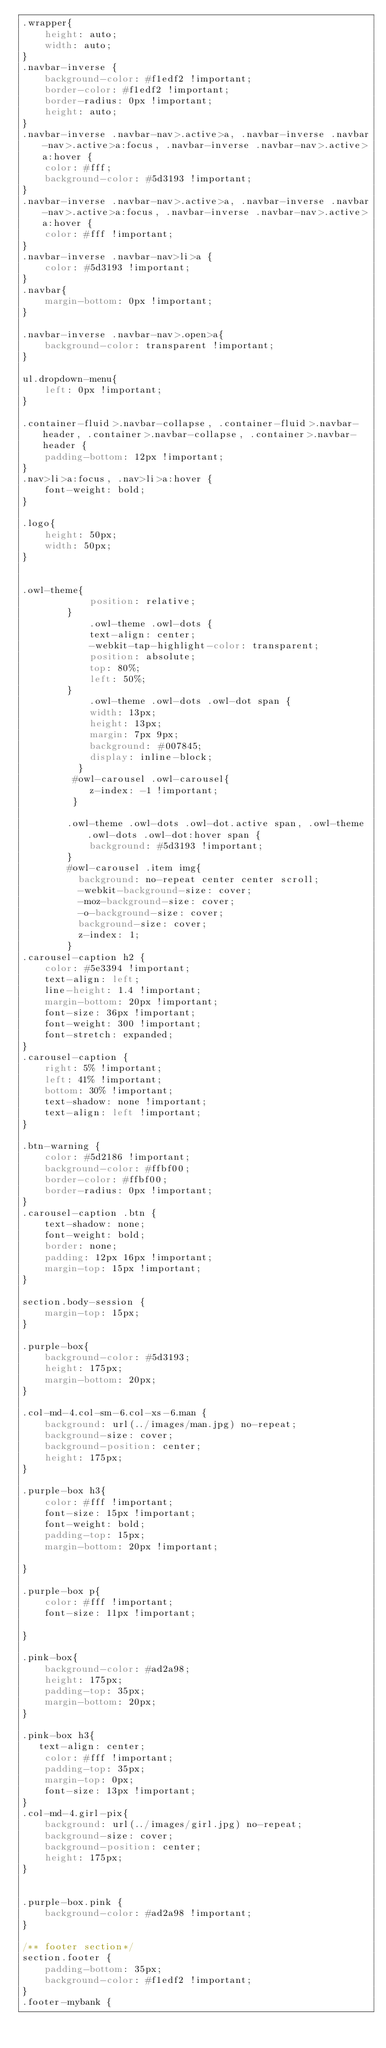Convert code to text. <code><loc_0><loc_0><loc_500><loc_500><_CSS_>.wrapper{
	height: auto;
	width: auto;
}
.navbar-inverse {
    background-color: #f1edf2 !important;
    border-color: #f1edf2 !important;
    border-radius: 0px !important;
    height: auto;
}
.navbar-inverse .navbar-nav>.active>a, .navbar-inverse .navbar-nav>.active>a:focus, .navbar-inverse .navbar-nav>.active>a:hover {
    color: #fff;
    background-color: #5d3193 !important;
}
.navbar-inverse .navbar-nav>.active>a, .navbar-inverse .navbar-nav>.active>a:focus, .navbar-inverse .navbar-nav>.active>a:hover {
    color: #fff !important;
}
.navbar-inverse .navbar-nav>li>a {
    color: #5d3193 !important;
}
.navbar{
    margin-bottom: 0px !important;
}

.navbar-inverse .navbar-nav>.open>a{
    background-color: transparent !important;
}

ul.dropdown-menu{
    left: 0px !important;
}

.container-fluid>.navbar-collapse, .container-fluid>.navbar-header, .container>.navbar-collapse, .container>.navbar-header {
    padding-bottom: 12px !important;
}
.nav>li>a:focus, .nav>li>a:hover {
    font-weight: bold;
}

.logo{
    height: 50px;
    width: 50px;
}


.owl-theme{
            position: relative;
        }
            .owl-theme .owl-dots {
            text-align: center;
            -webkit-tap-highlight-color: transparent;
            position: absolute;
            top: 80%;
            left: 50%;
        }
            .owl-theme .owl-dots .owl-dot span {
            width: 13px;
            height: 13px;
            margin: 7px 9px;
            background: #007845;
            display: inline-block;
          }
         #owl-carousel .owl-carousel{
            z-index: -1 !important;
         }

        .owl-theme .owl-dots .owl-dot.active span, .owl-theme .owl-dots .owl-dot:hover span {
            background: #5d3193 !important;
        }
        #owl-carousel .item img{
          background: no-repeat center center scroll;
          -webkit-background-size: cover;
          -moz-background-size: cover;
          -o-background-size: cover;
          background-size: cover;  
          z-index: 1;
        }
.carousel-caption h2 {
    color: #5e3394 !important;
    text-align: left;
    line-height: 1.4 !important;
    margin-bottom: 20px !important;
    font-size: 36px !important;
    font-weight: 300 !important;
    font-stretch: expanded;
}
.carousel-caption {
    right: 5% !important;
    left: 41% !important;
    bottom: 30% !important;
    text-shadow: none !important;
    text-align: left !important;
}

.btn-warning {
    color: #5d2186 !important;
    background-color: #ffbf00;
    border-color: #ffbf00;
    border-radius: 0px !important;
}
.carousel-caption .btn {
    text-shadow: none;
    font-weight: bold;
    border: none;
    padding: 12px 16px !important;
    margin-top: 15px !important;
}

section.body-session {
    margin-top: 15px;
}

.purple-box{
    background-color: #5d3193;
    height: 175px;
    margin-bottom: 20px;
}

.col-md-4.col-sm-6.col-xs-6.man {
    background: url(../images/man.jpg) no-repeat;
    background-size: cover;
    background-position: center;
    height: 175px;
}

.purple-box h3{
    color: #fff !important;
    font-size: 15px !important;
    font-weight: bold;
    padding-top: 15px;
    margin-bottom: 20px !important;

}

.purple-box p{
    color: #fff !important;
    font-size: 11px !important;
    
}

.pink-box{
    background-color: #ad2a98;
    height: 175px;
    padding-top: 35px;
    margin-bottom: 20px;
}

.pink-box h3{
   text-align: center;
    color: #fff !important;
    padding-top: 35px;
    margin-top: 0px;
    font-size: 13px !important;
}
.col-md-4.girl-pix{
    background: url(../images/girl.jpg) no-repeat;
    background-size: cover;
    background-position: center;
    height: 175px;
}


.purple-box.pink {
    background-color: #ad2a98 !important;
}

/** footer section*/
section.footer {
    padding-bottom: 35px;
    background-color: #f1edf2 !important;
}
.footer-mybank {</code> 